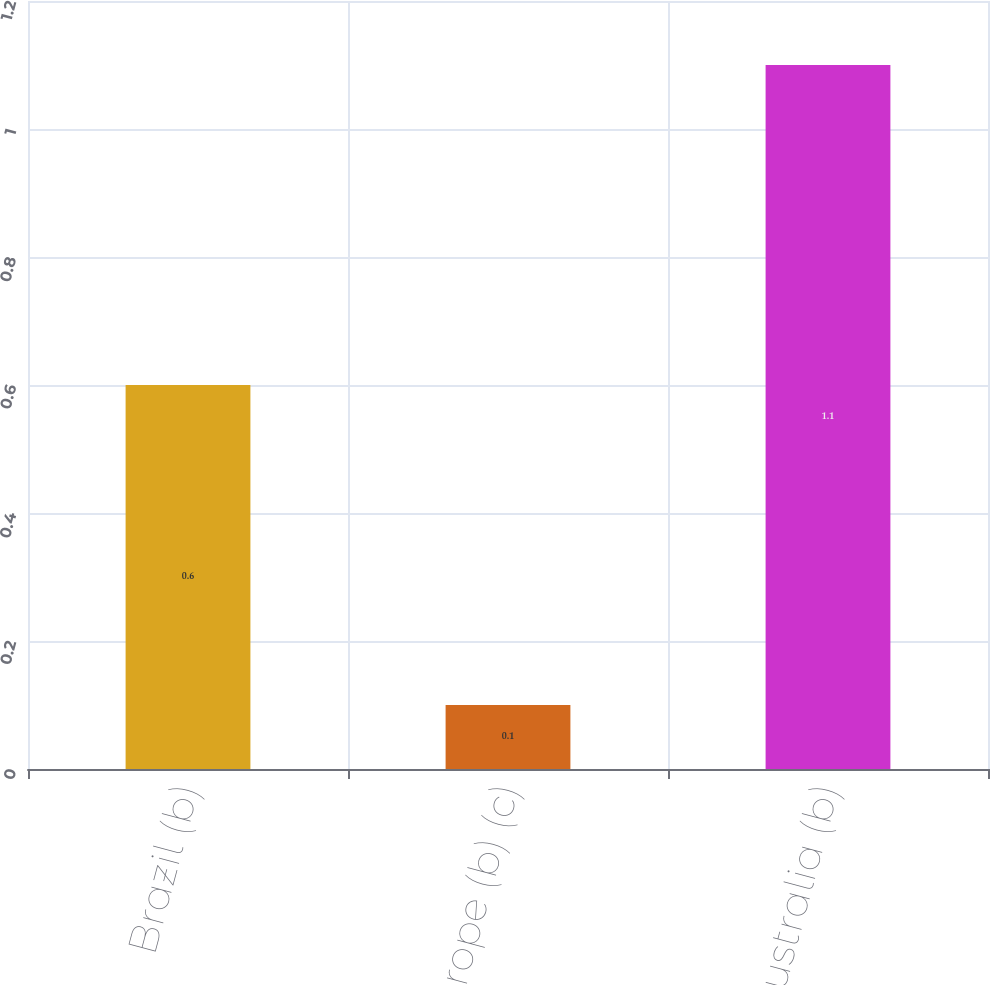Convert chart to OTSL. <chart><loc_0><loc_0><loc_500><loc_500><bar_chart><fcel>Brazil (b)<fcel>Europe (b) (c)<fcel>Australia (b)<nl><fcel>0.6<fcel>0.1<fcel>1.1<nl></chart> 